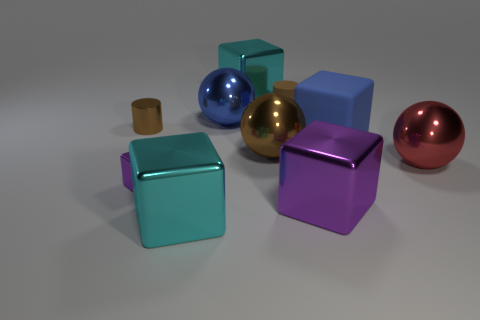Could you infer the potential texture of the objects? Based on their appearance, the metal balls likely have a smooth and reflective texture, typical of polished metals. The rubber cylinder appears to have a matte finish, suggesting a less reflective, possibly slightly rough or textured surface to the touch. The cubes might also have a matte finish with a plastic-like texture, smooth but without the shine of the metal spheres. 